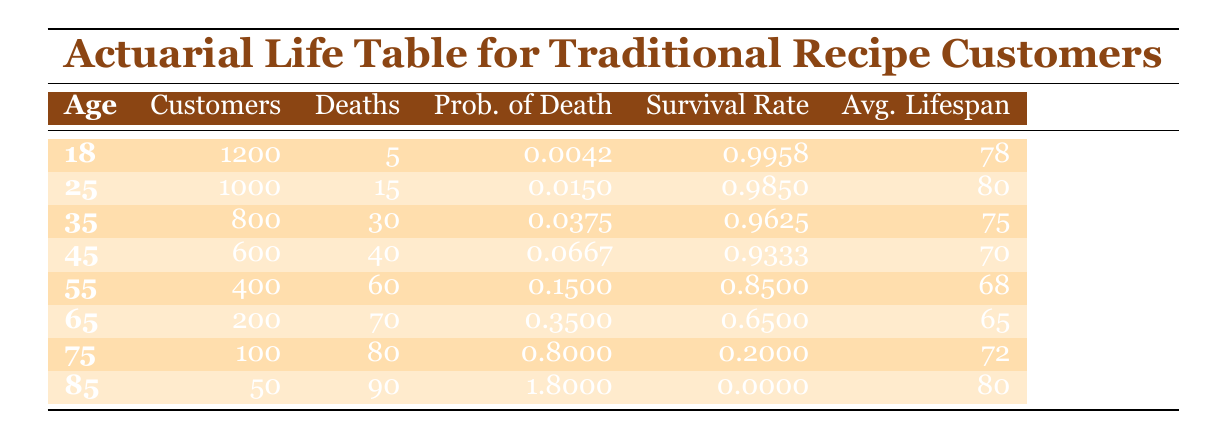What's the average lifespan of customers aged 25? Referring to the average lifespan column in the table, the value corresponds to the age of 25, which is 80 years.
Answer: 80 How many customers are alive at age 65? The number of customers at age 65 is found in the table under customers for that age, which shows 200 customers.
Answer: 200 What is the total number of deaths from ages 18 to 45? To find the total deaths from ages 18 to 45, we add the number of deaths for those ages: 5 + 15 + 30 + 40 = 90.
Answer: 90 Is the survival rate for customers aged 55 greater than 0.5? The survival rate for customers aged 55 is 0.85, which is greater than 0.5. Thus, the statement is true.
Answer: Yes What is the probability of death for customers aged 75? Checking the probability of death column for the age of 75, we find that the probability is 0.8.
Answer: 0.8 What is the average lifespan for the age group with the highest number of customers? The highest number of customers is at age 18 (1200 customers), and the average lifespan for this group is 78 years.
Answer: 78 How many more deaths occur in the age group of 65 compared to 55? The number of deaths at age 65 is 70 and at age 55 is 60. The difference is: 70 - 60 = 10 more deaths at age 65.
Answer: 10 What is the average lifespan of customers aged 45 and older? The average lifespans for ages 45, 55, 65, 75, and 85 are 70, 68, 65, 72, and 80 respectively. The average is calculated as (70 + 68 + 65 + 72 + 80) / 5 = 71.
Answer: 71 Are there any ages where the survival rate is below 0.2? Checking the survival rate, we see that at age 75, the survival rate is 0.2 and at age 85, it drops to 0. Therefore, the statement is true.
Answer: Yes 